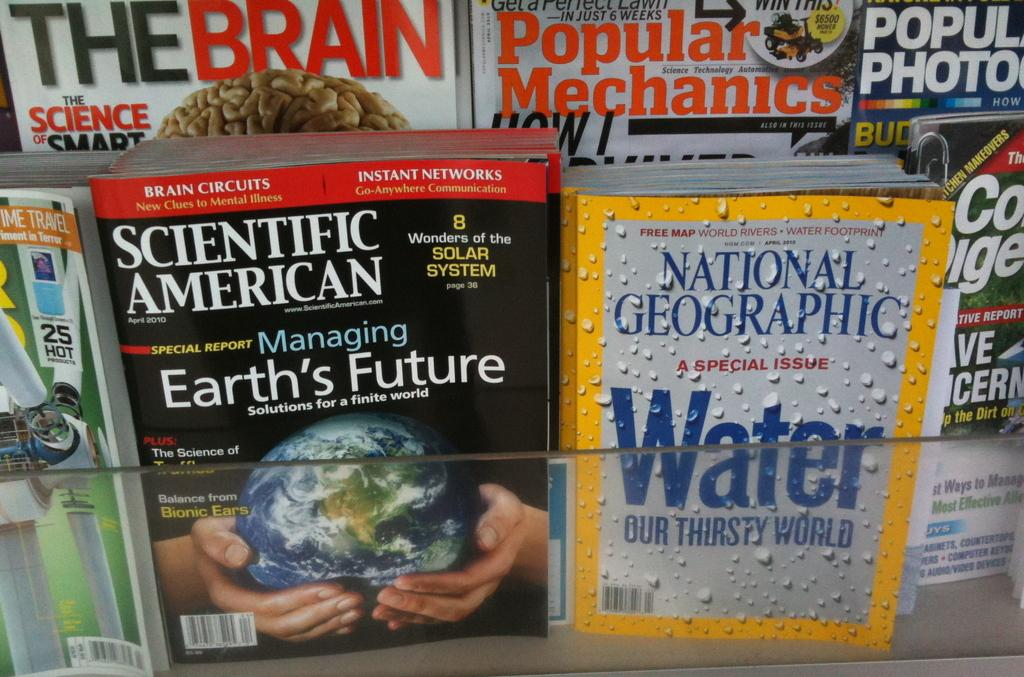<image>
Relay a brief, clear account of the picture shown. A magazine display including Popular Mechanics and National Geographic. 